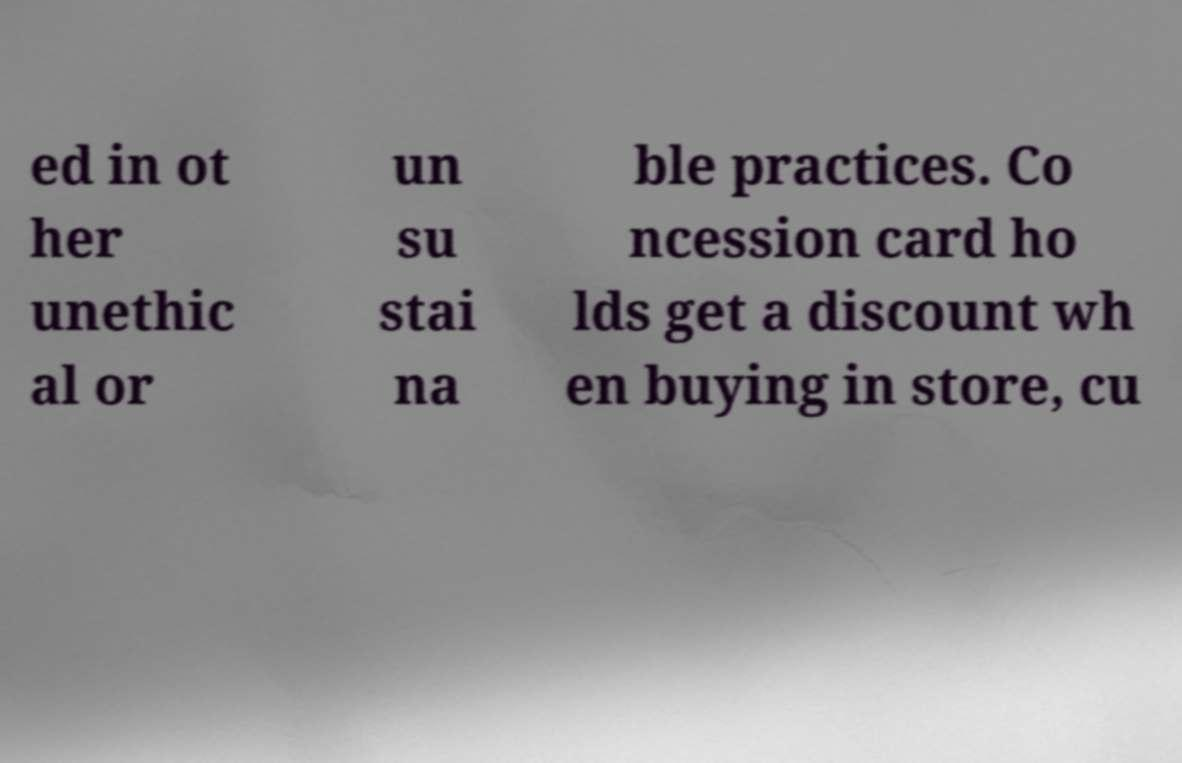What messages or text are displayed in this image? I need them in a readable, typed format. ed in ot her unethic al or un su stai na ble practices. Co ncession card ho lds get a discount wh en buying in store, cu 